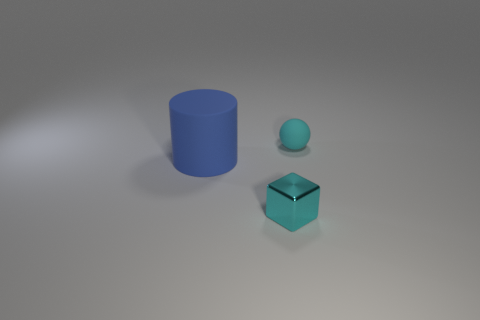Add 3 large purple shiny cylinders. How many objects exist? 6 Subtract all cylinders. How many objects are left? 2 Add 1 tiny blocks. How many tiny blocks are left? 2 Add 3 purple metal blocks. How many purple metal blocks exist? 3 Subtract 0 gray cylinders. How many objects are left? 3 Subtract all yellow shiny balls. Subtract all big blue matte things. How many objects are left? 2 